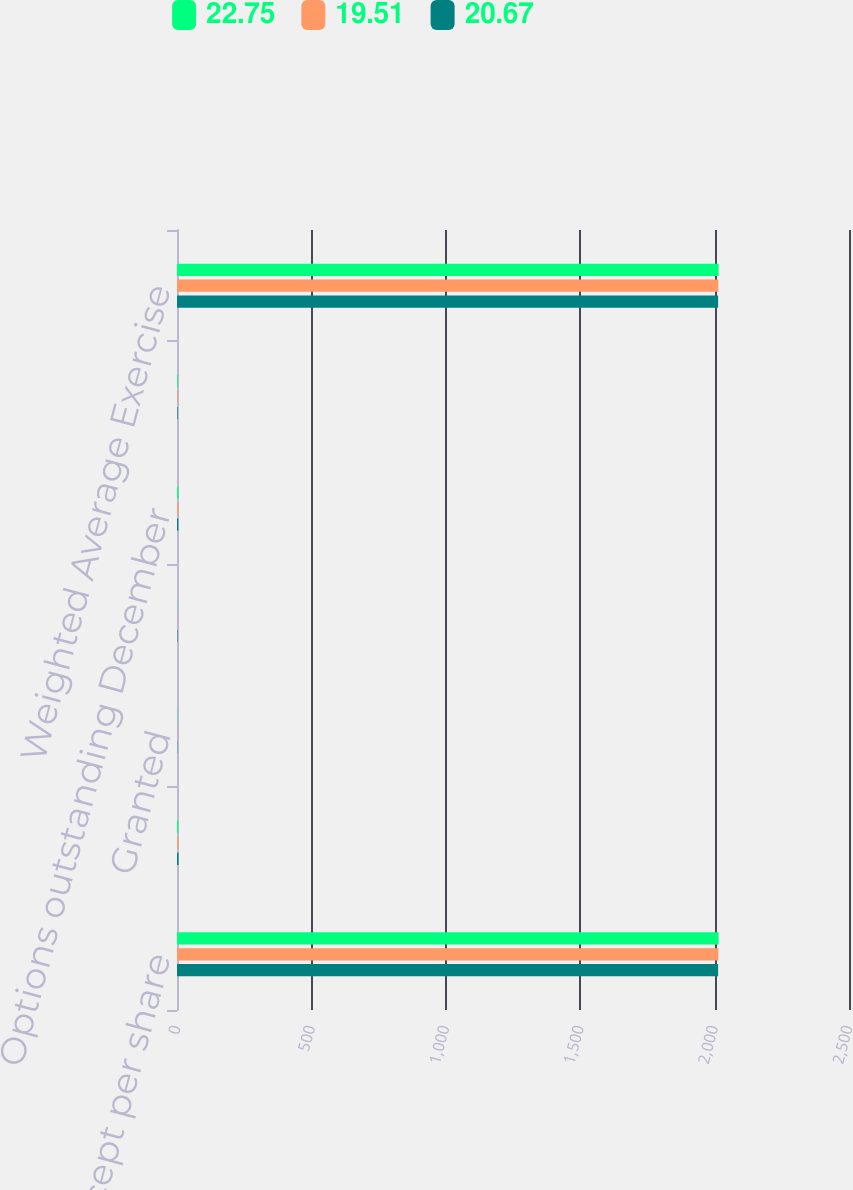<chart> <loc_0><loc_0><loc_500><loc_500><stacked_bar_chart><ecel><fcel>(in millions except per share<fcel>Options outstanding January 1<fcel>Granted<fcel>Exercised<fcel>Options outstanding December<fcel>Options exercisable December<fcel>Weighted Average Exercise<nl><fcel>22.75<fcel>2015<fcel>4.6<fcel>0.9<fcel>0.5<fcel>5<fcel>2.9<fcel>2015<nl><fcel>19.51<fcel>2014<fcel>4.8<fcel>0.7<fcel>0.7<fcel>4.6<fcel>2.6<fcel>2014<nl><fcel>20.67<fcel>2013<fcel>5.6<fcel>0.9<fcel>1.6<fcel>4.8<fcel>2.3<fcel>2013<nl></chart> 